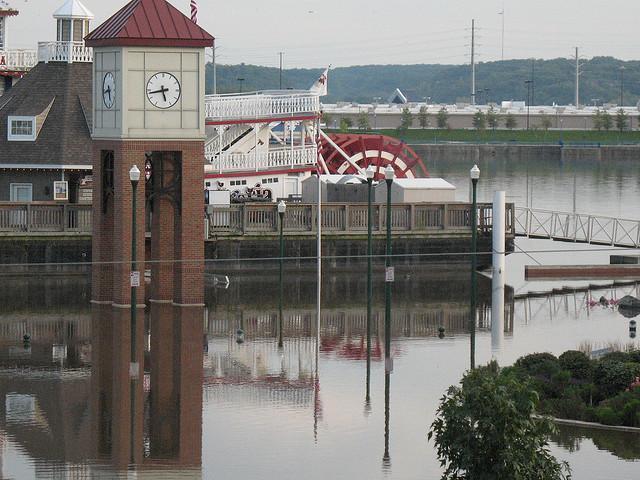How many blue airplanes are in the image?
Give a very brief answer. 0. 